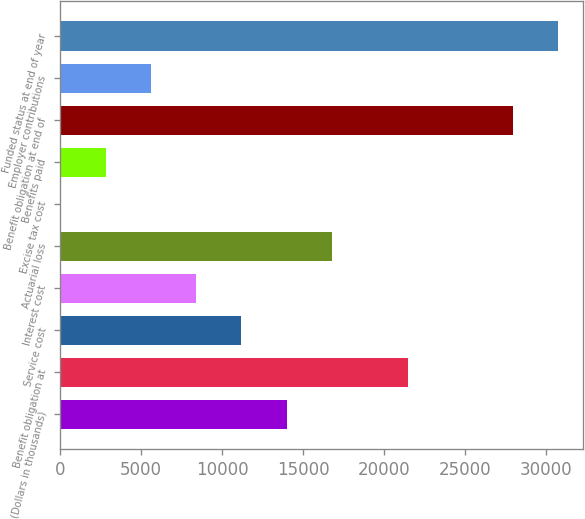Convert chart. <chart><loc_0><loc_0><loc_500><loc_500><bar_chart><fcel>(Dollars in thousands)<fcel>Benefit obligation at<fcel>Service cost<fcel>Interest cost<fcel>Actuarial loss<fcel>Excise tax cost<fcel>Benefits paid<fcel>Benefit obligation at end of<fcel>Employer contributions<fcel>Funded status at end of year<nl><fcel>13974.5<fcel>21462<fcel>11181.8<fcel>8389.1<fcel>16767.2<fcel>11<fcel>2803.7<fcel>27938<fcel>5596.4<fcel>30730.7<nl></chart> 